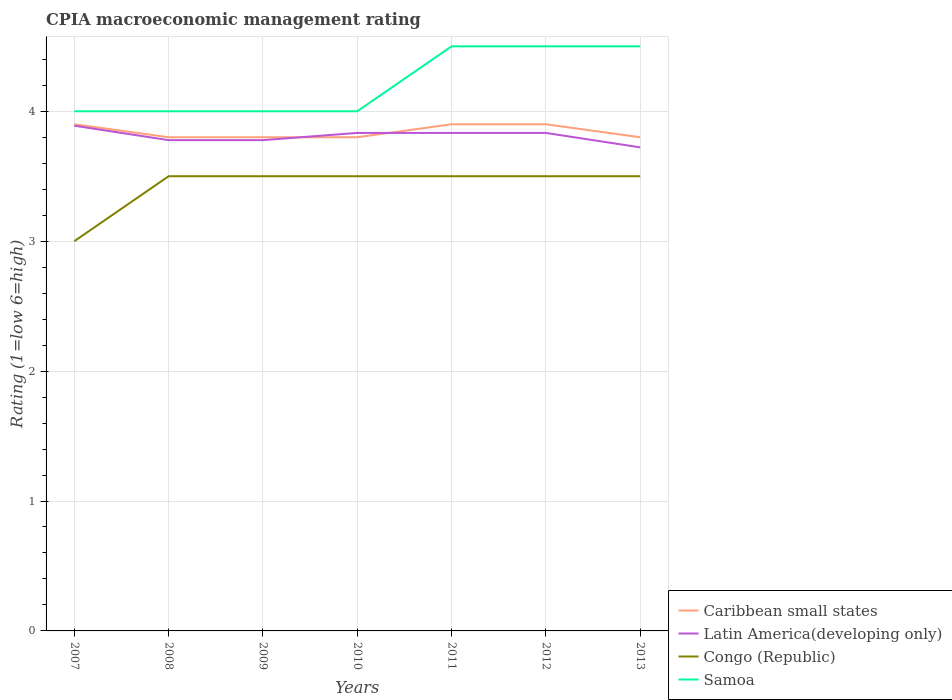How many different coloured lines are there?
Offer a very short reply. 4. Across all years, what is the maximum CPIA rating in Caribbean small states?
Give a very brief answer. 3.8. What is the total CPIA rating in Samoa in the graph?
Give a very brief answer. -0.5. What is the difference between the highest and the second highest CPIA rating in Congo (Republic)?
Provide a short and direct response. 0.5. What is the difference between the highest and the lowest CPIA rating in Latin America(developing only)?
Offer a terse response. 4. Does the graph contain any zero values?
Ensure brevity in your answer.  No. Does the graph contain grids?
Make the answer very short. Yes. How many legend labels are there?
Provide a short and direct response. 4. What is the title of the graph?
Make the answer very short. CPIA macroeconomic management rating. Does "Hong Kong" appear as one of the legend labels in the graph?
Your answer should be very brief. No. What is the label or title of the X-axis?
Your response must be concise. Years. What is the Rating (1=low 6=high) in Caribbean small states in 2007?
Offer a terse response. 3.9. What is the Rating (1=low 6=high) in Latin America(developing only) in 2007?
Keep it short and to the point. 3.89. What is the Rating (1=low 6=high) in Congo (Republic) in 2007?
Keep it short and to the point. 3. What is the Rating (1=low 6=high) in Samoa in 2007?
Give a very brief answer. 4. What is the Rating (1=low 6=high) in Caribbean small states in 2008?
Provide a succinct answer. 3.8. What is the Rating (1=low 6=high) in Latin America(developing only) in 2008?
Offer a terse response. 3.78. What is the Rating (1=low 6=high) of Congo (Republic) in 2008?
Keep it short and to the point. 3.5. What is the Rating (1=low 6=high) in Samoa in 2008?
Make the answer very short. 4. What is the Rating (1=low 6=high) in Latin America(developing only) in 2009?
Offer a terse response. 3.78. What is the Rating (1=low 6=high) of Samoa in 2009?
Offer a very short reply. 4. What is the Rating (1=low 6=high) of Latin America(developing only) in 2010?
Make the answer very short. 3.83. What is the Rating (1=low 6=high) in Congo (Republic) in 2010?
Offer a very short reply. 3.5. What is the Rating (1=low 6=high) of Latin America(developing only) in 2011?
Your response must be concise. 3.83. What is the Rating (1=low 6=high) of Caribbean small states in 2012?
Your answer should be compact. 3.9. What is the Rating (1=low 6=high) of Latin America(developing only) in 2012?
Ensure brevity in your answer.  3.83. What is the Rating (1=low 6=high) in Congo (Republic) in 2012?
Give a very brief answer. 3.5. What is the Rating (1=low 6=high) in Samoa in 2012?
Your answer should be very brief. 4.5. What is the Rating (1=low 6=high) in Caribbean small states in 2013?
Your answer should be very brief. 3.8. What is the Rating (1=low 6=high) of Latin America(developing only) in 2013?
Provide a succinct answer. 3.72. What is the Rating (1=low 6=high) of Samoa in 2013?
Offer a terse response. 4.5. Across all years, what is the maximum Rating (1=low 6=high) of Caribbean small states?
Your response must be concise. 3.9. Across all years, what is the maximum Rating (1=low 6=high) of Latin America(developing only)?
Provide a short and direct response. 3.89. Across all years, what is the maximum Rating (1=low 6=high) of Samoa?
Ensure brevity in your answer.  4.5. Across all years, what is the minimum Rating (1=low 6=high) in Caribbean small states?
Your answer should be compact. 3.8. Across all years, what is the minimum Rating (1=low 6=high) of Latin America(developing only)?
Make the answer very short. 3.72. Across all years, what is the minimum Rating (1=low 6=high) of Congo (Republic)?
Keep it short and to the point. 3. Across all years, what is the minimum Rating (1=low 6=high) in Samoa?
Keep it short and to the point. 4. What is the total Rating (1=low 6=high) in Caribbean small states in the graph?
Offer a very short reply. 26.9. What is the total Rating (1=low 6=high) in Latin America(developing only) in the graph?
Make the answer very short. 26.67. What is the total Rating (1=low 6=high) in Samoa in the graph?
Your answer should be compact. 29.5. What is the difference between the Rating (1=low 6=high) in Caribbean small states in 2007 and that in 2008?
Provide a short and direct response. 0.1. What is the difference between the Rating (1=low 6=high) of Congo (Republic) in 2007 and that in 2008?
Offer a very short reply. -0.5. What is the difference between the Rating (1=low 6=high) of Samoa in 2007 and that in 2008?
Provide a succinct answer. 0. What is the difference between the Rating (1=low 6=high) of Latin America(developing only) in 2007 and that in 2009?
Your answer should be compact. 0.11. What is the difference between the Rating (1=low 6=high) of Latin America(developing only) in 2007 and that in 2010?
Provide a short and direct response. 0.06. What is the difference between the Rating (1=low 6=high) of Congo (Republic) in 2007 and that in 2010?
Provide a succinct answer. -0.5. What is the difference between the Rating (1=low 6=high) of Caribbean small states in 2007 and that in 2011?
Your answer should be compact. 0. What is the difference between the Rating (1=low 6=high) in Latin America(developing only) in 2007 and that in 2011?
Provide a succinct answer. 0.06. What is the difference between the Rating (1=low 6=high) of Congo (Republic) in 2007 and that in 2011?
Offer a terse response. -0.5. What is the difference between the Rating (1=low 6=high) of Samoa in 2007 and that in 2011?
Keep it short and to the point. -0.5. What is the difference between the Rating (1=low 6=high) of Caribbean small states in 2007 and that in 2012?
Your answer should be compact. 0. What is the difference between the Rating (1=low 6=high) of Latin America(developing only) in 2007 and that in 2012?
Give a very brief answer. 0.06. What is the difference between the Rating (1=low 6=high) in Samoa in 2007 and that in 2012?
Ensure brevity in your answer.  -0.5. What is the difference between the Rating (1=low 6=high) of Caribbean small states in 2007 and that in 2013?
Give a very brief answer. 0.1. What is the difference between the Rating (1=low 6=high) in Latin America(developing only) in 2007 and that in 2013?
Offer a terse response. 0.17. What is the difference between the Rating (1=low 6=high) of Congo (Republic) in 2007 and that in 2013?
Give a very brief answer. -0.5. What is the difference between the Rating (1=low 6=high) of Samoa in 2008 and that in 2009?
Provide a succinct answer. 0. What is the difference between the Rating (1=low 6=high) in Latin America(developing only) in 2008 and that in 2010?
Your answer should be very brief. -0.06. What is the difference between the Rating (1=low 6=high) in Congo (Republic) in 2008 and that in 2010?
Make the answer very short. 0. What is the difference between the Rating (1=low 6=high) in Samoa in 2008 and that in 2010?
Offer a very short reply. 0. What is the difference between the Rating (1=low 6=high) in Caribbean small states in 2008 and that in 2011?
Your answer should be very brief. -0.1. What is the difference between the Rating (1=low 6=high) of Latin America(developing only) in 2008 and that in 2011?
Offer a very short reply. -0.06. What is the difference between the Rating (1=low 6=high) in Congo (Republic) in 2008 and that in 2011?
Make the answer very short. 0. What is the difference between the Rating (1=low 6=high) of Samoa in 2008 and that in 2011?
Keep it short and to the point. -0.5. What is the difference between the Rating (1=low 6=high) of Caribbean small states in 2008 and that in 2012?
Provide a succinct answer. -0.1. What is the difference between the Rating (1=low 6=high) of Latin America(developing only) in 2008 and that in 2012?
Provide a short and direct response. -0.06. What is the difference between the Rating (1=low 6=high) of Congo (Republic) in 2008 and that in 2012?
Provide a succinct answer. 0. What is the difference between the Rating (1=low 6=high) in Samoa in 2008 and that in 2012?
Your answer should be very brief. -0.5. What is the difference between the Rating (1=low 6=high) in Caribbean small states in 2008 and that in 2013?
Your answer should be compact. 0. What is the difference between the Rating (1=low 6=high) in Latin America(developing only) in 2008 and that in 2013?
Your answer should be compact. 0.06. What is the difference between the Rating (1=low 6=high) of Congo (Republic) in 2008 and that in 2013?
Give a very brief answer. 0. What is the difference between the Rating (1=low 6=high) of Latin America(developing only) in 2009 and that in 2010?
Give a very brief answer. -0.06. What is the difference between the Rating (1=low 6=high) of Samoa in 2009 and that in 2010?
Provide a succinct answer. 0. What is the difference between the Rating (1=low 6=high) in Latin America(developing only) in 2009 and that in 2011?
Offer a very short reply. -0.06. What is the difference between the Rating (1=low 6=high) in Congo (Republic) in 2009 and that in 2011?
Your answer should be very brief. 0. What is the difference between the Rating (1=low 6=high) in Latin America(developing only) in 2009 and that in 2012?
Your response must be concise. -0.06. What is the difference between the Rating (1=low 6=high) of Caribbean small states in 2009 and that in 2013?
Give a very brief answer. 0. What is the difference between the Rating (1=low 6=high) of Latin America(developing only) in 2009 and that in 2013?
Your answer should be very brief. 0.06. What is the difference between the Rating (1=low 6=high) in Caribbean small states in 2010 and that in 2011?
Keep it short and to the point. -0.1. What is the difference between the Rating (1=low 6=high) of Latin America(developing only) in 2010 and that in 2011?
Ensure brevity in your answer.  0. What is the difference between the Rating (1=low 6=high) in Congo (Republic) in 2010 and that in 2011?
Offer a very short reply. 0. What is the difference between the Rating (1=low 6=high) of Samoa in 2010 and that in 2011?
Give a very brief answer. -0.5. What is the difference between the Rating (1=low 6=high) of Caribbean small states in 2010 and that in 2012?
Keep it short and to the point. -0.1. What is the difference between the Rating (1=low 6=high) of Latin America(developing only) in 2010 and that in 2012?
Give a very brief answer. 0. What is the difference between the Rating (1=low 6=high) of Congo (Republic) in 2010 and that in 2012?
Provide a short and direct response. 0. What is the difference between the Rating (1=low 6=high) in Caribbean small states in 2010 and that in 2013?
Your answer should be very brief. 0. What is the difference between the Rating (1=low 6=high) of Congo (Republic) in 2010 and that in 2013?
Offer a very short reply. 0. What is the difference between the Rating (1=low 6=high) in Samoa in 2010 and that in 2013?
Offer a very short reply. -0.5. What is the difference between the Rating (1=low 6=high) of Caribbean small states in 2011 and that in 2012?
Give a very brief answer. 0. What is the difference between the Rating (1=low 6=high) of Samoa in 2011 and that in 2012?
Keep it short and to the point. 0. What is the difference between the Rating (1=low 6=high) of Congo (Republic) in 2011 and that in 2013?
Offer a terse response. 0. What is the difference between the Rating (1=low 6=high) of Congo (Republic) in 2012 and that in 2013?
Your answer should be compact. 0. What is the difference between the Rating (1=low 6=high) of Samoa in 2012 and that in 2013?
Make the answer very short. 0. What is the difference between the Rating (1=low 6=high) of Caribbean small states in 2007 and the Rating (1=low 6=high) of Latin America(developing only) in 2008?
Your response must be concise. 0.12. What is the difference between the Rating (1=low 6=high) of Caribbean small states in 2007 and the Rating (1=low 6=high) of Congo (Republic) in 2008?
Keep it short and to the point. 0.4. What is the difference between the Rating (1=low 6=high) in Caribbean small states in 2007 and the Rating (1=low 6=high) in Samoa in 2008?
Your response must be concise. -0.1. What is the difference between the Rating (1=low 6=high) in Latin America(developing only) in 2007 and the Rating (1=low 6=high) in Congo (Republic) in 2008?
Your answer should be very brief. 0.39. What is the difference between the Rating (1=low 6=high) of Latin America(developing only) in 2007 and the Rating (1=low 6=high) of Samoa in 2008?
Ensure brevity in your answer.  -0.11. What is the difference between the Rating (1=low 6=high) of Caribbean small states in 2007 and the Rating (1=low 6=high) of Latin America(developing only) in 2009?
Your answer should be very brief. 0.12. What is the difference between the Rating (1=low 6=high) in Caribbean small states in 2007 and the Rating (1=low 6=high) in Congo (Republic) in 2009?
Make the answer very short. 0.4. What is the difference between the Rating (1=low 6=high) in Latin America(developing only) in 2007 and the Rating (1=low 6=high) in Congo (Republic) in 2009?
Keep it short and to the point. 0.39. What is the difference between the Rating (1=low 6=high) of Latin America(developing only) in 2007 and the Rating (1=low 6=high) of Samoa in 2009?
Your answer should be very brief. -0.11. What is the difference between the Rating (1=low 6=high) of Congo (Republic) in 2007 and the Rating (1=low 6=high) of Samoa in 2009?
Make the answer very short. -1. What is the difference between the Rating (1=low 6=high) in Caribbean small states in 2007 and the Rating (1=low 6=high) in Latin America(developing only) in 2010?
Make the answer very short. 0.07. What is the difference between the Rating (1=low 6=high) of Caribbean small states in 2007 and the Rating (1=low 6=high) of Samoa in 2010?
Make the answer very short. -0.1. What is the difference between the Rating (1=low 6=high) in Latin America(developing only) in 2007 and the Rating (1=low 6=high) in Congo (Republic) in 2010?
Keep it short and to the point. 0.39. What is the difference between the Rating (1=low 6=high) of Latin America(developing only) in 2007 and the Rating (1=low 6=high) of Samoa in 2010?
Your response must be concise. -0.11. What is the difference between the Rating (1=low 6=high) of Caribbean small states in 2007 and the Rating (1=low 6=high) of Latin America(developing only) in 2011?
Offer a terse response. 0.07. What is the difference between the Rating (1=low 6=high) in Caribbean small states in 2007 and the Rating (1=low 6=high) in Samoa in 2011?
Your answer should be compact. -0.6. What is the difference between the Rating (1=low 6=high) in Latin America(developing only) in 2007 and the Rating (1=low 6=high) in Congo (Republic) in 2011?
Make the answer very short. 0.39. What is the difference between the Rating (1=low 6=high) in Latin America(developing only) in 2007 and the Rating (1=low 6=high) in Samoa in 2011?
Provide a short and direct response. -0.61. What is the difference between the Rating (1=low 6=high) of Caribbean small states in 2007 and the Rating (1=low 6=high) of Latin America(developing only) in 2012?
Provide a short and direct response. 0.07. What is the difference between the Rating (1=low 6=high) in Caribbean small states in 2007 and the Rating (1=low 6=high) in Congo (Republic) in 2012?
Your answer should be compact. 0.4. What is the difference between the Rating (1=low 6=high) in Caribbean small states in 2007 and the Rating (1=low 6=high) in Samoa in 2012?
Provide a short and direct response. -0.6. What is the difference between the Rating (1=low 6=high) in Latin America(developing only) in 2007 and the Rating (1=low 6=high) in Congo (Republic) in 2012?
Provide a short and direct response. 0.39. What is the difference between the Rating (1=low 6=high) of Latin America(developing only) in 2007 and the Rating (1=low 6=high) of Samoa in 2012?
Give a very brief answer. -0.61. What is the difference between the Rating (1=low 6=high) of Congo (Republic) in 2007 and the Rating (1=low 6=high) of Samoa in 2012?
Offer a terse response. -1.5. What is the difference between the Rating (1=low 6=high) in Caribbean small states in 2007 and the Rating (1=low 6=high) in Latin America(developing only) in 2013?
Offer a terse response. 0.18. What is the difference between the Rating (1=low 6=high) in Caribbean small states in 2007 and the Rating (1=low 6=high) in Congo (Republic) in 2013?
Offer a very short reply. 0.4. What is the difference between the Rating (1=low 6=high) in Caribbean small states in 2007 and the Rating (1=low 6=high) in Samoa in 2013?
Your response must be concise. -0.6. What is the difference between the Rating (1=low 6=high) of Latin America(developing only) in 2007 and the Rating (1=low 6=high) of Congo (Republic) in 2013?
Give a very brief answer. 0.39. What is the difference between the Rating (1=low 6=high) in Latin America(developing only) in 2007 and the Rating (1=low 6=high) in Samoa in 2013?
Provide a succinct answer. -0.61. What is the difference between the Rating (1=low 6=high) in Congo (Republic) in 2007 and the Rating (1=low 6=high) in Samoa in 2013?
Offer a terse response. -1.5. What is the difference between the Rating (1=low 6=high) of Caribbean small states in 2008 and the Rating (1=low 6=high) of Latin America(developing only) in 2009?
Provide a short and direct response. 0.02. What is the difference between the Rating (1=low 6=high) of Latin America(developing only) in 2008 and the Rating (1=low 6=high) of Congo (Republic) in 2009?
Make the answer very short. 0.28. What is the difference between the Rating (1=low 6=high) in Latin America(developing only) in 2008 and the Rating (1=low 6=high) in Samoa in 2009?
Offer a terse response. -0.22. What is the difference between the Rating (1=low 6=high) in Congo (Republic) in 2008 and the Rating (1=low 6=high) in Samoa in 2009?
Your response must be concise. -0.5. What is the difference between the Rating (1=low 6=high) of Caribbean small states in 2008 and the Rating (1=low 6=high) of Latin America(developing only) in 2010?
Your answer should be very brief. -0.03. What is the difference between the Rating (1=low 6=high) in Caribbean small states in 2008 and the Rating (1=low 6=high) in Samoa in 2010?
Ensure brevity in your answer.  -0.2. What is the difference between the Rating (1=low 6=high) of Latin America(developing only) in 2008 and the Rating (1=low 6=high) of Congo (Republic) in 2010?
Offer a very short reply. 0.28. What is the difference between the Rating (1=low 6=high) in Latin America(developing only) in 2008 and the Rating (1=low 6=high) in Samoa in 2010?
Provide a succinct answer. -0.22. What is the difference between the Rating (1=low 6=high) of Caribbean small states in 2008 and the Rating (1=low 6=high) of Latin America(developing only) in 2011?
Your answer should be compact. -0.03. What is the difference between the Rating (1=low 6=high) of Caribbean small states in 2008 and the Rating (1=low 6=high) of Congo (Republic) in 2011?
Offer a terse response. 0.3. What is the difference between the Rating (1=low 6=high) in Latin America(developing only) in 2008 and the Rating (1=low 6=high) in Congo (Republic) in 2011?
Your answer should be compact. 0.28. What is the difference between the Rating (1=low 6=high) in Latin America(developing only) in 2008 and the Rating (1=low 6=high) in Samoa in 2011?
Your response must be concise. -0.72. What is the difference between the Rating (1=low 6=high) in Caribbean small states in 2008 and the Rating (1=low 6=high) in Latin America(developing only) in 2012?
Keep it short and to the point. -0.03. What is the difference between the Rating (1=low 6=high) of Caribbean small states in 2008 and the Rating (1=low 6=high) of Samoa in 2012?
Give a very brief answer. -0.7. What is the difference between the Rating (1=low 6=high) in Latin America(developing only) in 2008 and the Rating (1=low 6=high) in Congo (Republic) in 2012?
Make the answer very short. 0.28. What is the difference between the Rating (1=low 6=high) of Latin America(developing only) in 2008 and the Rating (1=low 6=high) of Samoa in 2012?
Your response must be concise. -0.72. What is the difference between the Rating (1=low 6=high) in Congo (Republic) in 2008 and the Rating (1=low 6=high) in Samoa in 2012?
Provide a short and direct response. -1. What is the difference between the Rating (1=low 6=high) in Caribbean small states in 2008 and the Rating (1=low 6=high) in Latin America(developing only) in 2013?
Ensure brevity in your answer.  0.08. What is the difference between the Rating (1=low 6=high) in Caribbean small states in 2008 and the Rating (1=low 6=high) in Congo (Republic) in 2013?
Offer a terse response. 0.3. What is the difference between the Rating (1=low 6=high) in Caribbean small states in 2008 and the Rating (1=low 6=high) in Samoa in 2013?
Ensure brevity in your answer.  -0.7. What is the difference between the Rating (1=low 6=high) of Latin America(developing only) in 2008 and the Rating (1=low 6=high) of Congo (Republic) in 2013?
Provide a succinct answer. 0.28. What is the difference between the Rating (1=low 6=high) in Latin America(developing only) in 2008 and the Rating (1=low 6=high) in Samoa in 2013?
Provide a short and direct response. -0.72. What is the difference between the Rating (1=low 6=high) in Caribbean small states in 2009 and the Rating (1=low 6=high) in Latin America(developing only) in 2010?
Your response must be concise. -0.03. What is the difference between the Rating (1=low 6=high) of Caribbean small states in 2009 and the Rating (1=low 6=high) of Samoa in 2010?
Provide a short and direct response. -0.2. What is the difference between the Rating (1=low 6=high) of Latin America(developing only) in 2009 and the Rating (1=low 6=high) of Congo (Republic) in 2010?
Ensure brevity in your answer.  0.28. What is the difference between the Rating (1=low 6=high) in Latin America(developing only) in 2009 and the Rating (1=low 6=high) in Samoa in 2010?
Ensure brevity in your answer.  -0.22. What is the difference between the Rating (1=low 6=high) in Congo (Republic) in 2009 and the Rating (1=low 6=high) in Samoa in 2010?
Your response must be concise. -0.5. What is the difference between the Rating (1=low 6=high) in Caribbean small states in 2009 and the Rating (1=low 6=high) in Latin America(developing only) in 2011?
Give a very brief answer. -0.03. What is the difference between the Rating (1=low 6=high) in Caribbean small states in 2009 and the Rating (1=low 6=high) in Congo (Republic) in 2011?
Make the answer very short. 0.3. What is the difference between the Rating (1=low 6=high) of Latin America(developing only) in 2009 and the Rating (1=low 6=high) of Congo (Republic) in 2011?
Give a very brief answer. 0.28. What is the difference between the Rating (1=low 6=high) in Latin America(developing only) in 2009 and the Rating (1=low 6=high) in Samoa in 2011?
Offer a terse response. -0.72. What is the difference between the Rating (1=low 6=high) of Congo (Republic) in 2009 and the Rating (1=low 6=high) of Samoa in 2011?
Offer a terse response. -1. What is the difference between the Rating (1=low 6=high) in Caribbean small states in 2009 and the Rating (1=low 6=high) in Latin America(developing only) in 2012?
Your answer should be very brief. -0.03. What is the difference between the Rating (1=low 6=high) in Latin America(developing only) in 2009 and the Rating (1=low 6=high) in Congo (Republic) in 2012?
Provide a short and direct response. 0.28. What is the difference between the Rating (1=low 6=high) in Latin America(developing only) in 2009 and the Rating (1=low 6=high) in Samoa in 2012?
Offer a terse response. -0.72. What is the difference between the Rating (1=low 6=high) of Congo (Republic) in 2009 and the Rating (1=low 6=high) of Samoa in 2012?
Offer a very short reply. -1. What is the difference between the Rating (1=low 6=high) in Caribbean small states in 2009 and the Rating (1=low 6=high) in Latin America(developing only) in 2013?
Provide a succinct answer. 0.08. What is the difference between the Rating (1=low 6=high) of Caribbean small states in 2009 and the Rating (1=low 6=high) of Congo (Republic) in 2013?
Your answer should be very brief. 0.3. What is the difference between the Rating (1=low 6=high) of Latin America(developing only) in 2009 and the Rating (1=low 6=high) of Congo (Republic) in 2013?
Make the answer very short. 0.28. What is the difference between the Rating (1=low 6=high) of Latin America(developing only) in 2009 and the Rating (1=low 6=high) of Samoa in 2013?
Provide a succinct answer. -0.72. What is the difference between the Rating (1=low 6=high) of Congo (Republic) in 2009 and the Rating (1=low 6=high) of Samoa in 2013?
Offer a very short reply. -1. What is the difference between the Rating (1=low 6=high) of Caribbean small states in 2010 and the Rating (1=low 6=high) of Latin America(developing only) in 2011?
Keep it short and to the point. -0.03. What is the difference between the Rating (1=low 6=high) in Caribbean small states in 2010 and the Rating (1=low 6=high) in Samoa in 2011?
Your response must be concise. -0.7. What is the difference between the Rating (1=low 6=high) in Latin America(developing only) in 2010 and the Rating (1=low 6=high) in Congo (Republic) in 2011?
Your answer should be very brief. 0.33. What is the difference between the Rating (1=low 6=high) of Congo (Republic) in 2010 and the Rating (1=low 6=high) of Samoa in 2011?
Ensure brevity in your answer.  -1. What is the difference between the Rating (1=low 6=high) of Caribbean small states in 2010 and the Rating (1=low 6=high) of Latin America(developing only) in 2012?
Keep it short and to the point. -0.03. What is the difference between the Rating (1=low 6=high) of Caribbean small states in 2010 and the Rating (1=low 6=high) of Samoa in 2012?
Ensure brevity in your answer.  -0.7. What is the difference between the Rating (1=low 6=high) of Latin America(developing only) in 2010 and the Rating (1=low 6=high) of Congo (Republic) in 2012?
Your answer should be compact. 0.33. What is the difference between the Rating (1=low 6=high) of Latin America(developing only) in 2010 and the Rating (1=low 6=high) of Samoa in 2012?
Provide a succinct answer. -0.67. What is the difference between the Rating (1=low 6=high) in Caribbean small states in 2010 and the Rating (1=low 6=high) in Latin America(developing only) in 2013?
Your answer should be very brief. 0.08. What is the difference between the Rating (1=low 6=high) of Caribbean small states in 2010 and the Rating (1=low 6=high) of Congo (Republic) in 2013?
Offer a very short reply. 0.3. What is the difference between the Rating (1=low 6=high) of Caribbean small states in 2010 and the Rating (1=low 6=high) of Samoa in 2013?
Keep it short and to the point. -0.7. What is the difference between the Rating (1=low 6=high) in Latin America(developing only) in 2010 and the Rating (1=low 6=high) in Congo (Republic) in 2013?
Your response must be concise. 0.33. What is the difference between the Rating (1=low 6=high) in Caribbean small states in 2011 and the Rating (1=low 6=high) in Latin America(developing only) in 2012?
Offer a terse response. 0.07. What is the difference between the Rating (1=low 6=high) in Caribbean small states in 2011 and the Rating (1=low 6=high) in Samoa in 2012?
Keep it short and to the point. -0.6. What is the difference between the Rating (1=low 6=high) in Latin America(developing only) in 2011 and the Rating (1=low 6=high) in Congo (Republic) in 2012?
Give a very brief answer. 0.33. What is the difference between the Rating (1=low 6=high) of Latin America(developing only) in 2011 and the Rating (1=low 6=high) of Samoa in 2012?
Provide a succinct answer. -0.67. What is the difference between the Rating (1=low 6=high) of Caribbean small states in 2011 and the Rating (1=low 6=high) of Latin America(developing only) in 2013?
Offer a terse response. 0.18. What is the difference between the Rating (1=low 6=high) in Latin America(developing only) in 2011 and the Rating (1=low 6=high) in Congo (Republic) in 2013?
Your answer should be very brief. 0.33. What is the difference between the Rating (1=low 6=high) of Latin America(developing only) in 2011 and the Rating (1=low 6=high) of Samoa in 2013?
Your answer should be compact. -0.67. What is the difference between the Rating (1=low 6=high) of Caribbean small states in 2012 and the Rating (1=low 6=high) of Latin America(developing only) in 2013?
Make the answer very short. 0.18. What is the difference between the Rating (1=low 6=high) in Latin America(developing only) in 2012 and the Rating (1=low 6=high) in Samoa in 2013?
Ensure brevity in your answer.  -0.67. What is the difference between the Rating (1=low 6=high) in Congo (Republic) in 2012 and the Rating (1=low 6=high) in Samoa in 2013?
Ensure brevity in your answer.  -1. What is the average Rating (1=low 6=high) in Caribbean small states per year?
Keep it short and to the point. 3.84. What is the average Rating (1=low 6=high) of Latin America(developing only) per year?
Offer a terse response. 3.81. What is the average Rating (1=low 6=high) of Congo (Republic) per year?
Provide a short and direct response. 3.43. What is the average Rating (1=low 6=high) of Samoa per year?
Provide a succinct answer. 4.21. In the year 2007, what is the difference between the Rating (1=low 6=high) of Caribbean small states and Rating (1=low 6=high) of Latin America(developing only)?
Offer a terse response. 0.01. In the year 2007, what is the difference between the Rating (1=low 6=high) of Latin America(developing only) and Rating (1=low 6=high) of Samoa?
Provide a short and direct response. -0.11. In the year 2008, what is the difference between the Rating (1=low 6=high) in Caribbean small states and Rating (1=low 6=high) in Latin America(developing only)?
Provide a short and direct response. 0.02. In the year 2008, what is the difference between the Rating (1=low 6=high) of Caribbean small states and Rating (1=low 6=high) of Congo (Republic)?
Give a very brief answer. 0.3. In the year 2008, what is the difference between the Rating (1=low 6=high) in Latin America(developing only) and Rating (1=low 6=high) in Congo (Republic)?
Offer a very short reply. 0.28. In the year 2008, what is the difference between the Rating (1=low 6=high) in Latin America(developing only) and Rating (1=low 6=high) in Samoa?
Your answer should be compact. -0.22. In the year 2008, what is the difference between the Rating (1=low 6=high) of Congo (Republic) and Rating (1=low 6=high) of Samoa?
Your answer should be compact. -0.5. In the year 2009, what is the difference between the Rating (1=low 6=high) of Caribbean small states and Rating (1=low 6=high) of Latin America(developing only)?
Offer a very short reply. 0.02. In the year 2009, what is the difference between the Rating (1=low 6=high) of Latin America(developing only) and Rating (1=low 6=high) of Congo (Republic)?
Your response must be concise. 0.28. In the year 2009, what is the difference between the Rating (1=low 6=high) in Latin America(developing only) and Rating (1=low 6=high) in Samoa?
Your response must be concise. -0.22. In the year 2010, what is the difference between the Rating (1=low 6=high) in Caribbean small states and Rating (1=low 6=high) in Latin America(developing only)?
Ensure brevity in your answer.  -0.03. In the year 2010, what is the difference between the Rating (1=low 6=high) in Latin America(developing only) and Rating (1=low 6=high) in Congo (Republic)?
Make the answer very short. 0.33. In the year 2010, what is the difference between the Rating (1=low 6=high) of Latin America(developing only) and Rating (1=low 6=high) of Samoa?
Provide a succinct answer. -0.17. In the year 2011, what is the difference between the Rating (1=low 6=high) in Caribbean small states and Rating (1=low 6=high) in Latin America(developing only)?
Your response must be concise. 0.07. In the year 2012, what is the difference between the Rating (1=low 6=high) of Caribbean small states and Rating (1=low 6=high) of Latin America(developing only)?
Your answer should be very brief. 0.07. In the year 2012, what is the difference between the Rating (1=low 6=high) of Caribbean small states and Rating (1=low 6=high) of Congo (Republic)?
Ensure brevity in your answer.  0.4. In the year 2012, what is the difference between the Rating (1=low 6=high) of Caribbean small states and Rating (1=low 6=high) of Samoa?
Give a very brief answer. -0.6. In the year 2012, what is the difference between the Rating (1=low 6=high) in Latin America(developing only) and Rating (1=low 6=high) in Congo (Republic)?
Ensure brevity in your answer.  0.33. In the year 2012, what is the difference between the Rating (1=low 6=high) of Latin America(developing only) and Rating (1=low 6=high) of Samoa?
Your answer should be compact. -0.67. In the year 2013, what is the difference between the Rating (1=low 6=high) of Caribbean small states and Rating (1=low 6=high) of Latin America(developing only)?
Give a very brief answer. 0.08. In the year 2013, what is the difference between the Rating (1=low 6=high) of Caribbean small states and Rating (1=low 6=high) of Congo (Republic)?
Your answer should be compact. 0.3. In the year 2013, what is the difference between the Rating (1=low 6=high) of Caribbean small states and Rating (1=low 6=high) of Samoa?
Offer a terse response. -0.7. In the year 2013, what is the difference between the Rating (1=low 6=high) in Latin America(developing only) and Rating (1=low 6=high) in Congo (Republic)?
Make the answer very short. 0.22. In the year 2013, what is the difference between the Rating (1=low 6=high) of Latin America(developing only) and Rating (1=low 6=high) of Samoa?
Provide a short and direct response. -0.78. What is the ratio of the Rating (1=low 6=high) in Caribbean small states in 2007 to that in 2008?
Make the answer very short. 1.03. What is the ratio of the Rating (1=low 6=high) in Latin America(developing only) in 2007 to that in 2008?
Make the answer very short. 1.03. What is the ratio of the Rating (1=low 6=high) of Samoa in 2007 to that in 2008?
Offer a terse response. 1. What is the ratio of the Rating (1=low 6=high) of Caribbean small states in 2007 to that in 2009?
Ensure brevity in your answer.  1.03. What is the ratio of the Rating (1=low 6=high) of Latin America(developing only) in 2007 to that in 2009?
Your answer should be very brief. 1.03. What is the ratio of the Rating (1=low 6=high) in Samoa in 2007 to that in 2009?
Keep it short and to the point. 1. What is the ratio of the Rating (1=low 6=high) in Caribbean small states in 2007 to that in 2010?
Give a very brief answer. 1.03. What is the ratio of the Rating (1=low 6=high) in Latin America(developing only) in 2007 to that in 2010?
Offer a terse response. 1.01. What is the ratio of the Rating (1=low 6=high) in Latin America(developing only) in 2007 to that in 2011?
Keep it short and to the point. 1.01. What is the ratio of the Rating (1=low 6=high) in Congo (Republic) in 2007 to that in 2011?
Your answer should be compact. 0.86. What is the ratio of the Rating (1=low 6=high) in Samoa in 2007 to that in 2011?
Your answer should be compact. 0.89. What is the ratio of the Rating (1=low 6=high) in Latin America(developing only) in 2007 to that in 2012?
Keep it short and to the point. 1.01. What is the ratio of the Rating (1=low 6=high) in Caribbean small states in 2007 to that in 2013?
Keep it short and to the point. 1.03. What is the ratio of the Rating (1=low 6=high) in Latin America(developing only) in 2007 to that in 2013?
Keep it short and to the point. 1.04. What is the ratio of the Rating (1=low 6=high) of Samoa in 2007 to that in 2013?
Make the answer very short. 0.89. What is the ratio of the Rating (1=low 6=high) of Samoa in 2008 to that in 2009?
Make the answer very short. 1. What is the ratio of the Rating (1=low 6=high) of Latin America(developing only) in 2008 to that in 2010?
Offer a terse response. 0.99. What is the ratio of the Rating (1=low 6=high) of Congo (Republic) in 2008 to that in 2010?
Offer a very short reply. 1. What is the ratio of the Rating (1=low 6=high) of Samoa in 2008 to that in 2010?
Provide a short and direct response. 1. What is the ratio of the Rating (1=low 6=high) in Caribbean small states in 2008 to that in 2011?
Your answer should be very brief. 0.97. What is the ratio of the Rating (1=low 6=high) in Latin America(developing only) in 2008 to that in 2011?
Your response must be concise. 0.99. What is the ratio of the Rating (1=low 6=high) of Caribbean small states in 2008 to that in 2012?
Offer a terse response. 0.97. What is the ratio of the Rating (1=low 6=high) of Latin America(developing only) in 2008 to that in 2012?
Provide a short and direct response. 0.99. What is the ratio of the Rating (1=low 6=high) in Latin America(developing only) in 2008 to that in 2013?
Offer a very short reply. 1.01. What is the ratio of the Rating (1=low 6=high) in Caribbean small states in 2009 to that in 2010?
Keep it short and to the point. 1. What is the ratio of the Rating (1=low 6=high) of Latin America(developing only) in 2009 to that in 2010?
Your answer should be compact. 0.99. What is the ratio of the Rating (1=low 6=high) of Caribbean small states in 2009 to that in 2011?
Offer a very short reply. 0.97. What is the ratio of the Rating (1=low 6=high) of Latin America(developing only) in 2009 to that in 2011?
Keep it short and to the point. 0.99. What is the ratio of the Rating (1=low 6=high) in Congo (Republic) in 2009 to that in 2011?
Provide a succinct answer. 1. What is the ratio of the Rating (1=low 6=high) of Caribbean small states in 2009 to that in 2012?
Offer a very short reply. 0.97. What is the ratio of the Rating (1=low 6=high) of Latin America(developing only) in 2009 to that in 2012?
Your response must be concise. 0.99. What is the ratio of the Rating (1=low 6=high) of Congo (Republic) in 2009 to that in 2012?
Ensure brevity in your answer.  1. What is the ratio of the Rating (1=low 6=high) of Samoa in 2009 to that in 2012?
Offer a terse response. 0.89. What is the ratio of the Rating (1=low 6=high) in Caribbean small states in 2009 to that in 2013?
Make the answer very short. 1. What is the ratio of the Rating (1=low 6=high) of Latin America(developing only) in 2009 to that in 2013?
Keep it short and to the point. 1.01. What is the ratio of the Rating (1=low 6=high) in Congo (Republic) in 2009 to that in 2013?
Make the answer very short. 1. What is the ratio of the Rating (1=low 6=high) in Samoa in 2009 to that in 2013?
Make the answer very short. 0.89. What is the ratio of the Rating (1=low 6=high) in Caribbean small states in 2010 to that in 2011?
Ensure brevity in your answer.  0.97. What is the ratio of the Rating (1=low 6=high) in Caribbean small states in 2010 to that in 2012?
Make the answer very short. 0.97. What is the ratio of the Rating (1=low 6=high) in Congo (Republic) in 2010 to that in 2012?
Offer a terse response. 1. What is the ratio of the Rating (1=low 6=high) in Latin America(developing only) in 2010 to that in 2013?
Ensure brevity in your answer.  1.03. What is the ratio of the Rating (1=low 6=high) in Congo (Republic) in 2010 to that in 2013?
Give a very brief answer. 1. What is the ratio of the Rating (1=low 6=high) in Samoa in 2010 to that in 2013?
Give a very brief answer. 0.89. What is the ratio of the Rating (1=low 6=high) of Caribbean small states in 2011 to that in 2012?
Your response must be concise. 1. What is the ratio of the Rating (1=low 6=high) of Latin America(developing only) in 2011 to that in 2012?
Provide a succinct answer. 1. What is the ratio of the Rating (1=low 6=high) of Congo (Republic) in 2011 to that in 2012?
Give a very brief answer. 1. What is the ratio of the Rating (1=low 6=high) of Caribbean small states in 2011 to that in 2013?
Provide a succinct answer. 1.03. What is the ratio of the Rating (1=low 6=high) of Latin America(developing only) in 2011 to that in 2013?
Give a very brief answer. 1.03. What is the ratio of the Rating (1=low 6=high) in Caribbean small states in 2012 to that in 2013?
Provide a short and direct response. 1.03. What is the ratio of the Rating (1=low 6=high) of Latin America(developing only) in 2012 to that in 2013?
Your answer should be compact. 1.03. What is the difference between the highest and the second highest Rating (1=low 6=high) in Latin America(developing only)?
Offer a terse response. 0.06. What is the difference between the highest and the lowest Rating (1=low 6=high) of Caribbean small states?
Keep it short and to the point. 0.1. What is the difference between the highest and the lowest Rating (1=low 6=high) of Congo (Republic)?
Provide a short and direct response. 0.5. 